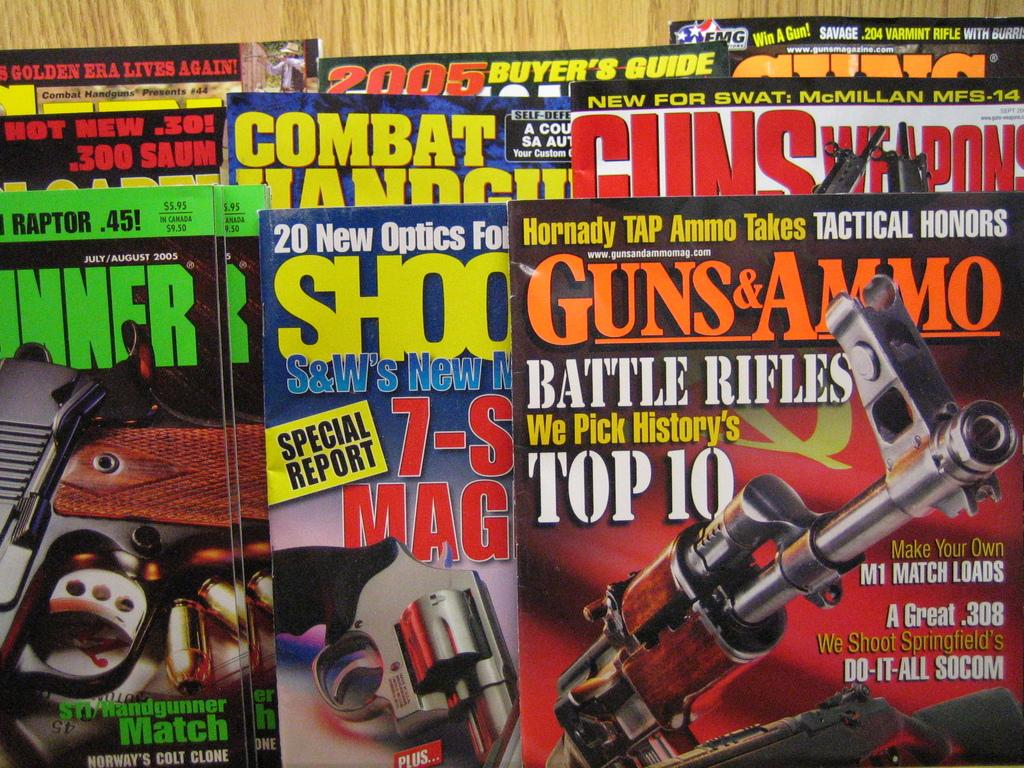<image>
Share a concise interpretation of the image provided. Magazines for Guns and Ammo, Guns Weapons, Shooter, et cetera 